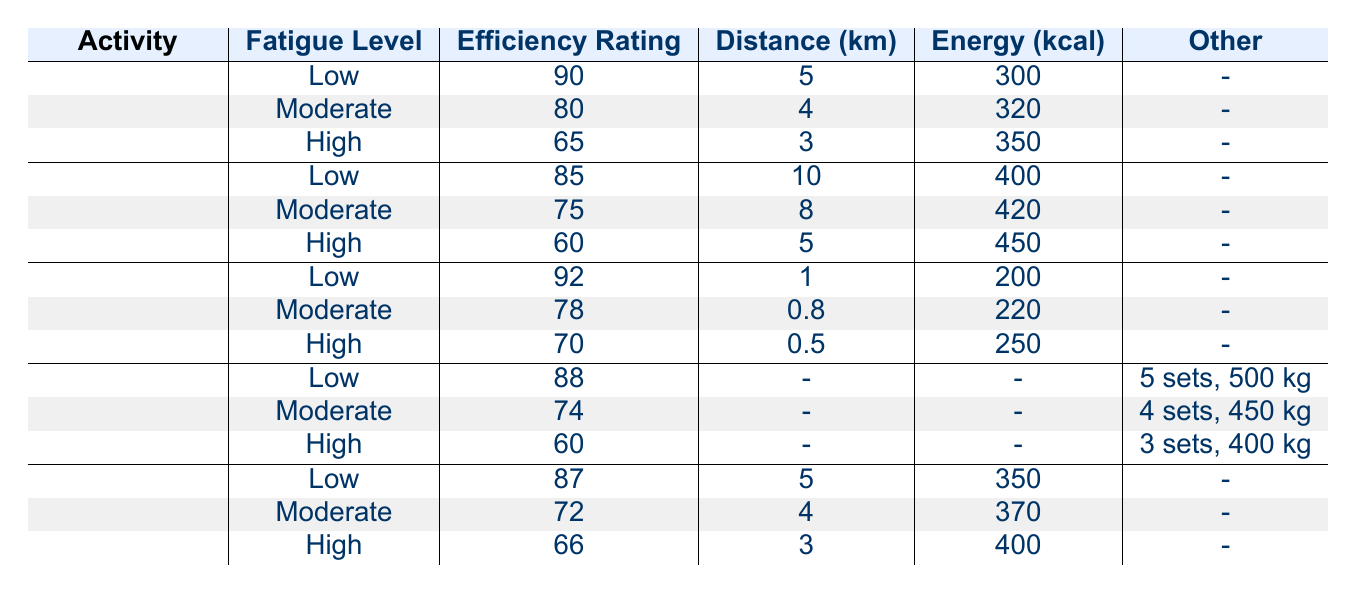What is the efficiency rating for running at a high fatigue level? In the table, for the activity of running at a high fatigue level, the efficiency rating is clearly listed as 65.
Answer: 65 What activity has the highest efficiency rating at low fatigue? Analyzing the table, the highest efficiency rating at low fatigue is found in swimming, which is rated at 92.
Answer: Swimming How much distance is covered in cycling at moderate fatigue compared to low fatigue? For cycling at low fatigue, the distance covered is 10 km, while at moderate fatigue, it is 8 km. The difference in distance is 10 - 8 = 2 km.
Answer: 2 km Does swimming at high fatigue require more energy expenditure than weightlifting at moderate fatigue? Swimming at high fatigue has an energy expenditure of 250 kcal while weightlifting at moderate fatigue has an energy expenditure of 0 kcal (no energy value provided). Since 250 is greater than 0, the statement is false.
Answer: No What is the average efficiency rating for rowing across all fatigue levels? The efficiency ratings for rowing are 87 (low), 72 (moderate), and 66 (high). The average is calculated as (87 + 72 + 66) / 3 = 225 / 3 = 75.
Answer: 75 What is the total energy expenditure for running at moderate and high fatigue levels? For running at moderate fatigue, the energy expenditure is 320 kcal, and at high fatigue, it is 350 kcal. Adding these values gives 320 + 350 = 670 kcal.
Answer: 670 kcal Which activity has the lowest efficiency rating at high fatigue? The activities listed in the table show that cycling has an efficiency rating of 60 at high fatigue, which is the lowest when compared to running (65), swimming (70), weightlifting (60), and rowing (66).
Answer: Cycling What is the relationship between fatigue level and energy expenditure in cycling? Observing the table for cycling: low fatigue (400 kcal), moderate fatigue (420 kcal), and high fatigue (450 kcal). The energy expenditure increases as fatigue level increases, indicating a direct relationship.
Answer: Direct relationship 